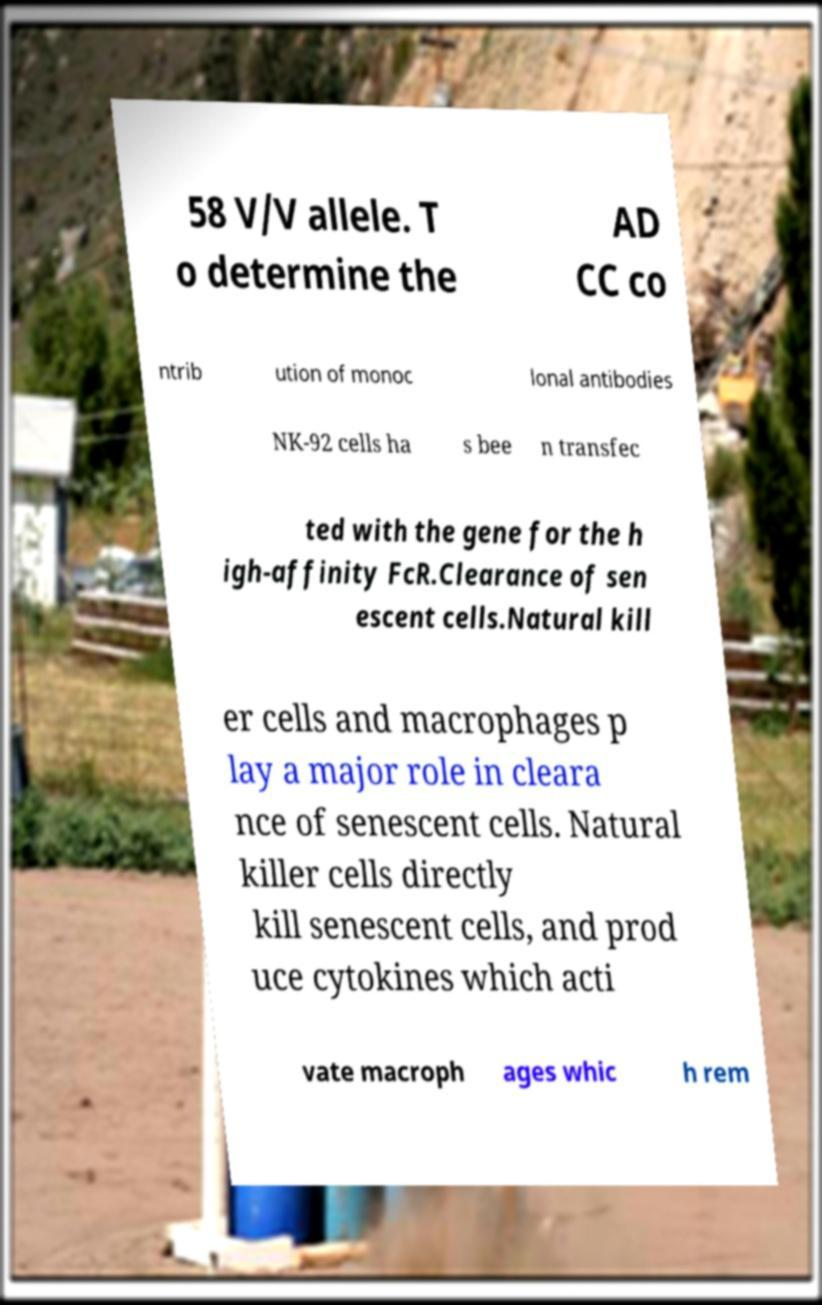Could you assist in decoding the text presented in this image and type it out clearly? 58 V/V allele. T o determine the AD CC co ntrib ution of monoc lonal antibodies NK-92 cells ha s bee n transfec ted with the gene for the h igh-affinity FcR.Clearance of sen escent cells.Natural kill er cells and macrophages p lay a major role in cleara nce of senescent cells. Natural killer cells directly kill senescent cells, and prod uce cytokines which acti vate macroph ages whic h rem 